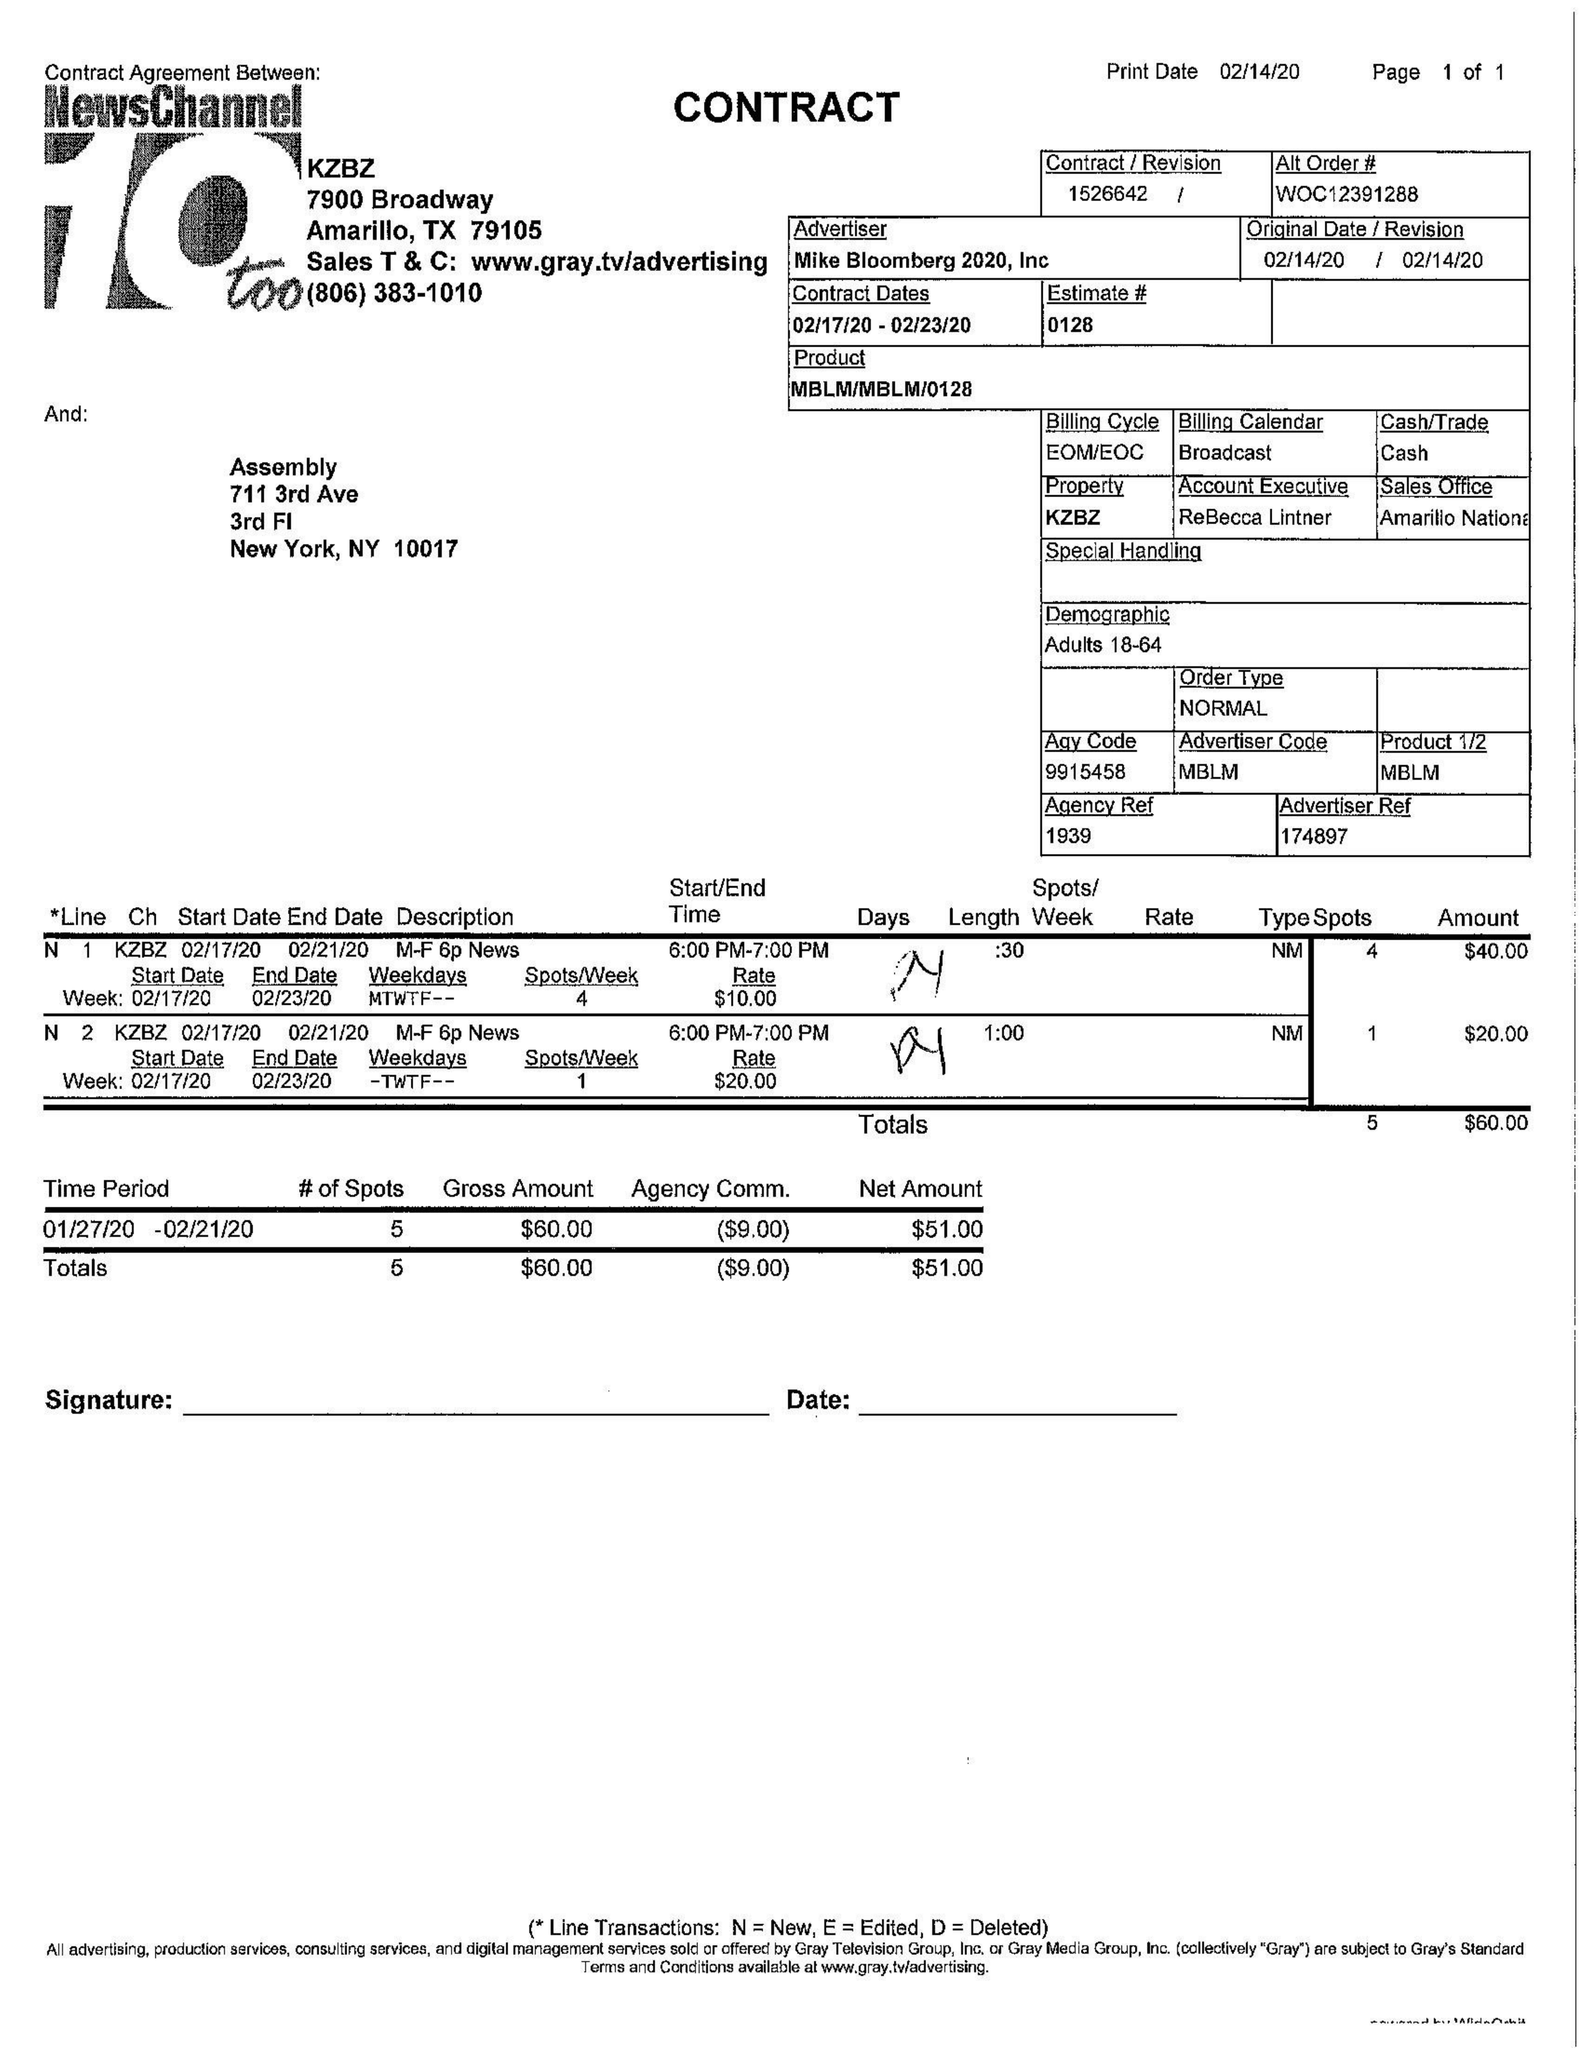What is the value for the flight_to?
Answer the question using a single word or phrase. 02/23/20 